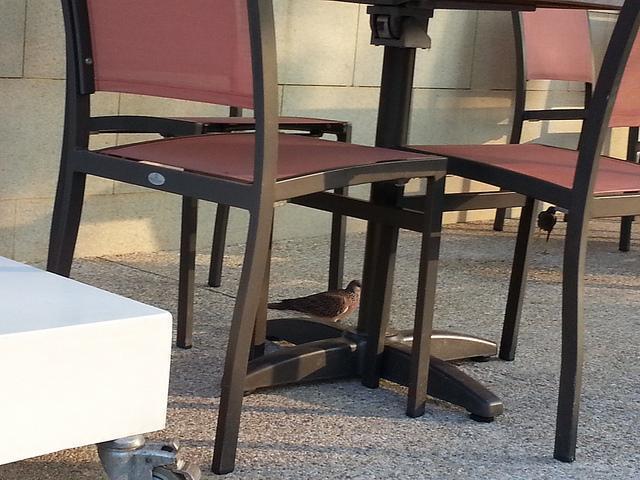How many chairs are there?
Give a very brief answer. 4. 